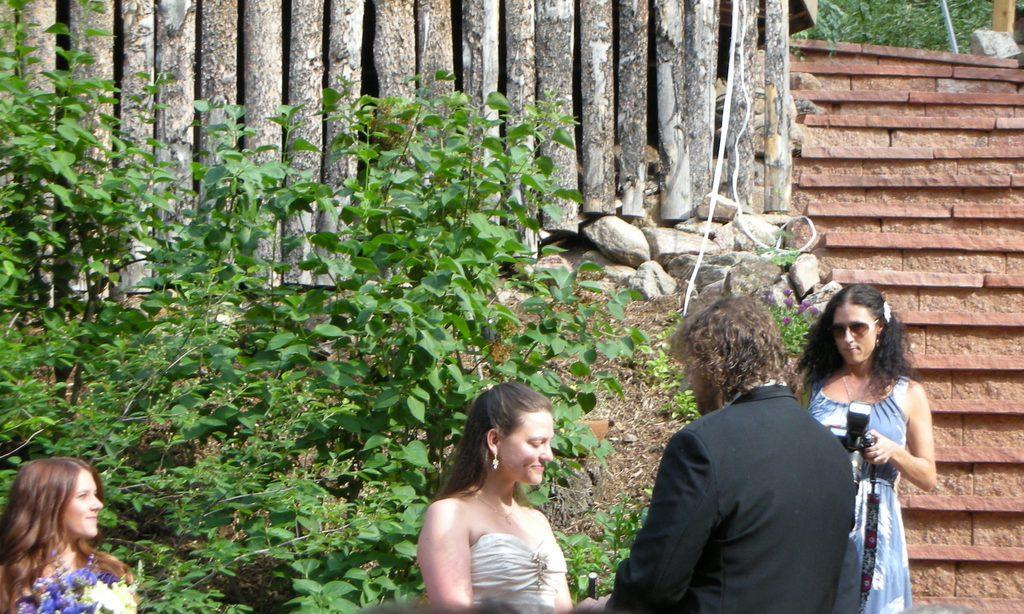Could you give a brief overview of what you see in this image? As we can see in the image, there are four people standing in the front and there is a tree over here. 